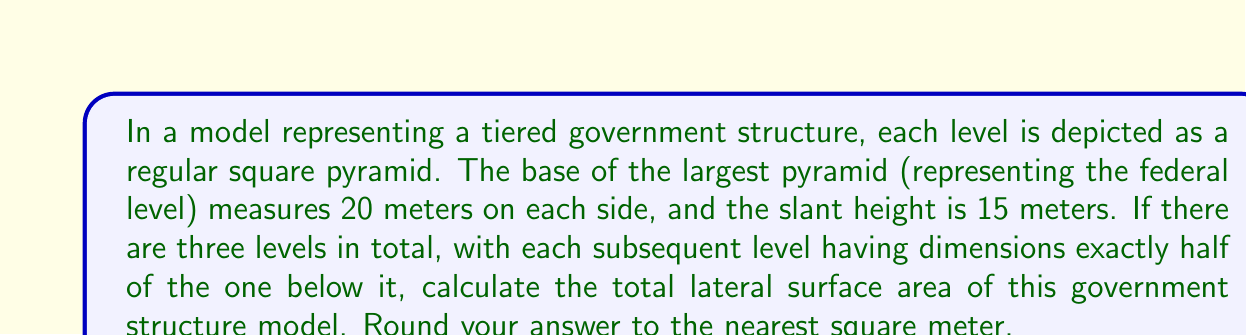Help me with this question. Let's approach this step-by-step:

1) First, let's calculate the lateral surface area of the largest pyramid (federal level):
   - Base side length: $a_1 = 20$ m
   - Slant height: $s_1 = 15$ m
   - Lateral surface area of a square pyramid: $LSA = 4 \cdot \frac{1}{2}as$
   - $LSA_1 = 4 \cdot \frac{1}{2} \cdot 20 \cdot 15 = 600$ m²

2) For the second level (state level):
   - Base side length: $a_2 = \frac{20}{2} = 10$ m
   - Slant height: $s_2 = \frac{15}{2} = 7.5$ m
   - $LSA_2 = 4 \cdot \frac{1}{2} \cdot 10 \cdot 7.5 = 150$ m²

3) For the third level (local level):
   - Base side length: $a_3 = \frac{10}{2} = 5$ m
   - Slant height: $s_3 = \frac{7.5}{2} = 3.75$ m
   - $LSA_3 = 4 \cdot \frac{1}{2} \cdot 5 \cdot 3.75 = 37.5$ m²

4) Total lateral surface area:
   $LSA_{total} = LSA_1 + LSA_2 + LSA_3$
   $LSA_{total} = 600 + 150 + 37.5 = 787.5$ m²

5) Rounding to the nearest square meter:
   $LSA_{total} \approx 788$ m²
Answer: 788 m² 